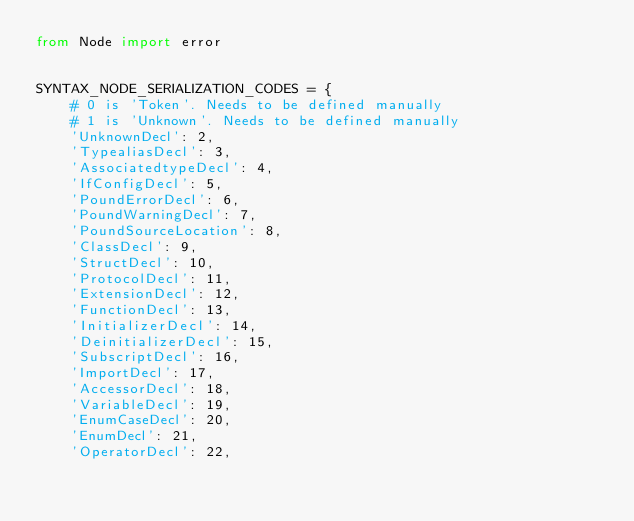<code> <loc_0><loc_0><loc_500><loc_500><_Python_>from Node import error


SYNTAX_NODE_SERIALIZATION_CODES = {
    # 0 is 'Token'. Needs to be defined manually
    # 1 is 'Unknown'. Needs to be defined manually
    'UnknownDecl': 2,
    'TypealiasDecl': 3,
    'AssociatedtypeDecl': 4,
    'IfConfigDecl': 5,
    'PoundErrorDecl': 6,
    'PoundWarningDecl': 7,
    'PoundSourceLocation': 8,
    'ClassDecl': 9,
    'StructDecl': 10,
    'ProtocolDecl': 11,
    'ExtensionDecl': 12,
    'FunctionDecl': 13,
    'InitializerDecl': 14,
    'DeinitializerDecl': 15,
    'SubscriptDecl': 16,
    'ImportDecl': 17,
    'AccessorDecl': 18,
    'VariableDecl': 19,
    'EnumCaseDecl': 20,
    'EnumDecl': 21,
    'OperatorDecl': 22,</code> 